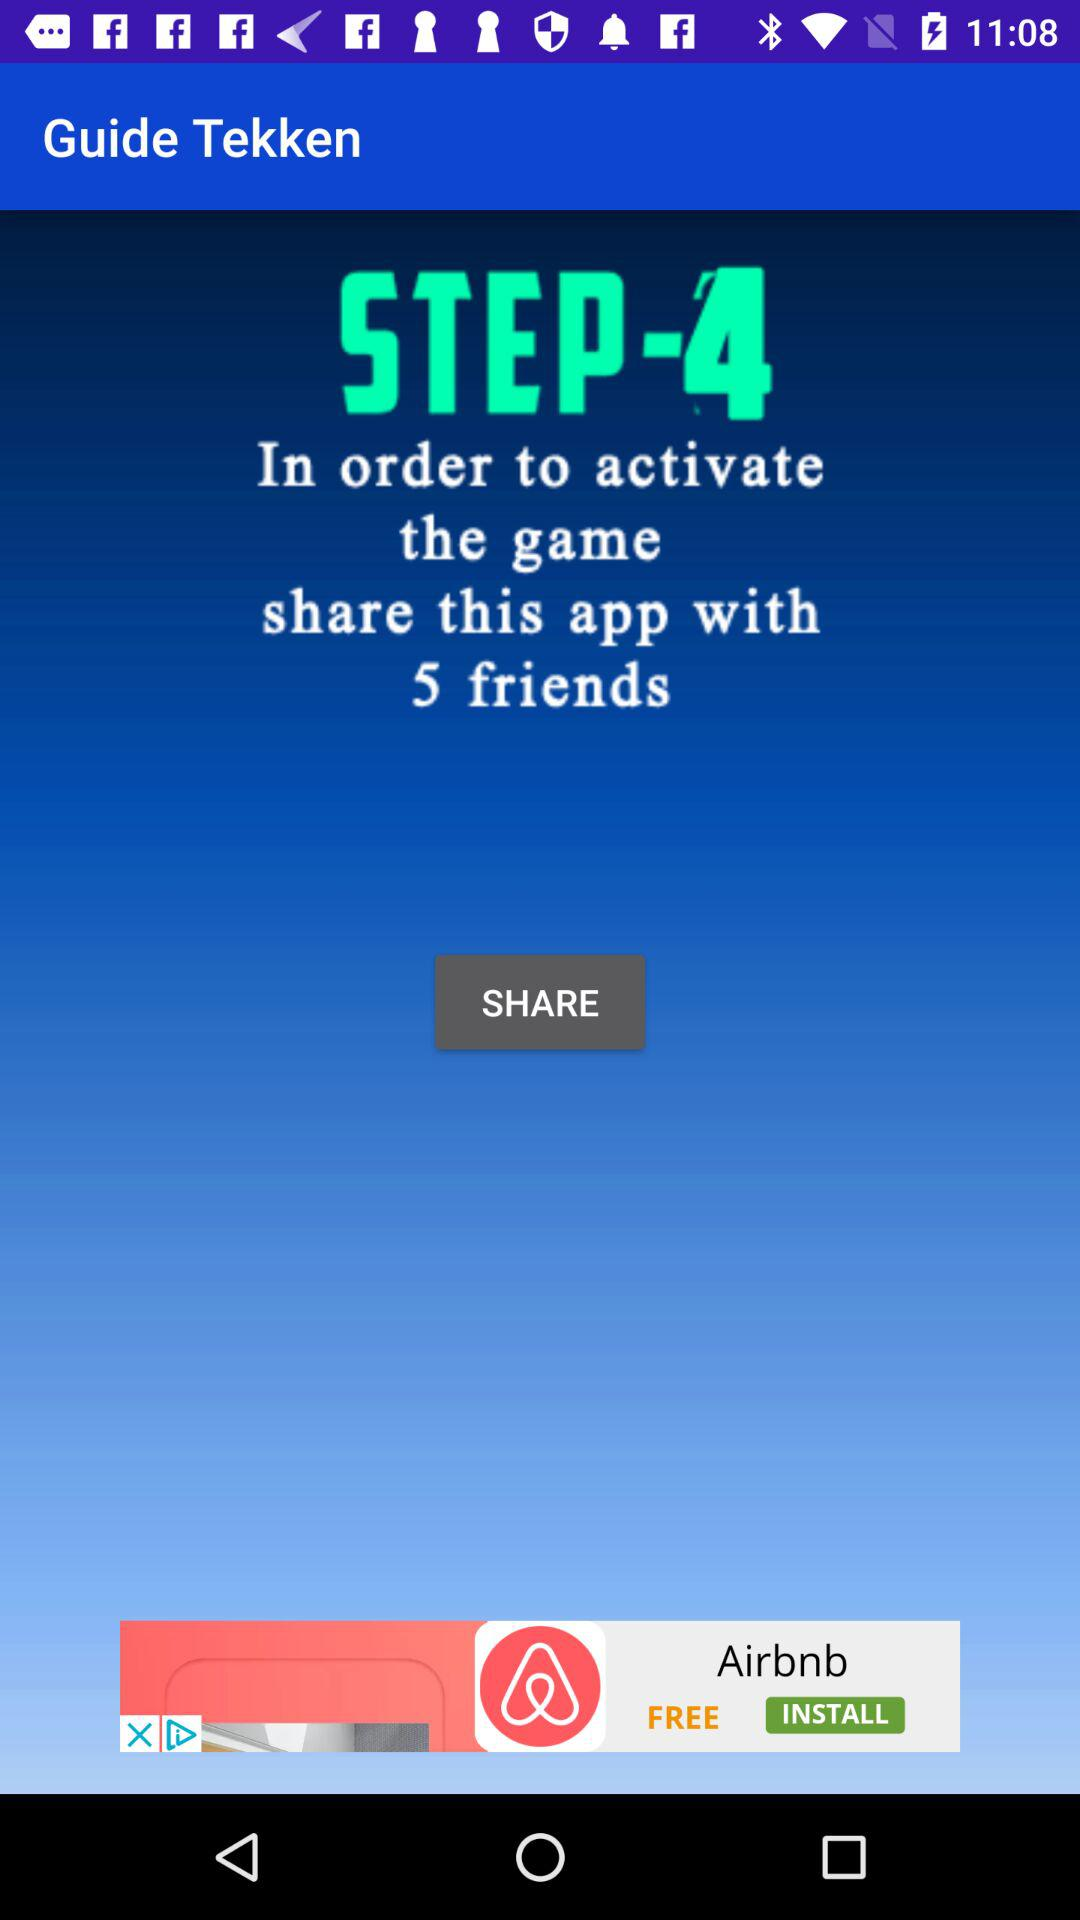Which applications are available for sharing?
When the provided information is insufficient, respond with <no answer>. <no answer> 